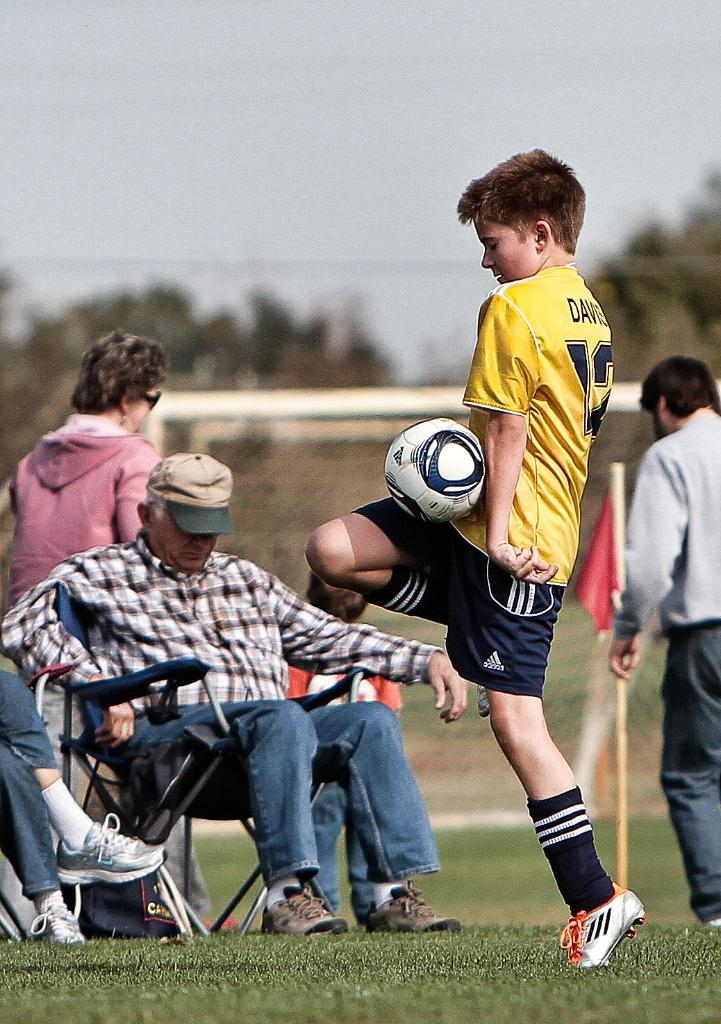What is happening in the image involving a group of people? One person is playing with a ball. Can you describe the activity taking place in the image? There is a group of people, and one person is playing with a ball. What is the condition of the background in the image? The background of the image is blurry. Where is the faucet located in the image? There is no faucet present in the image. What type of border surrounds the group of people in the image? There is no border surrounding the group of people in the image. 